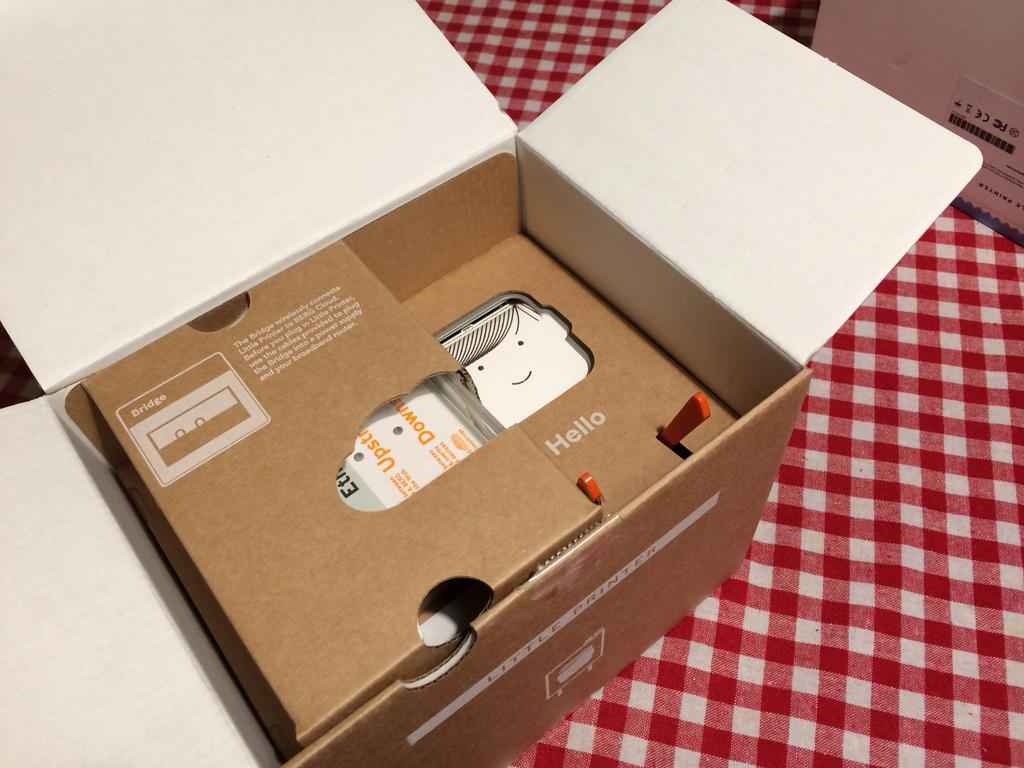How many boxes are visible in the image? There are two boxes in the image. What is the surface on which the boxes are placed? The boxes are on a cloth. Are there any objects inside either of the boxes? Yes, there are objects inside one of the boxes. How many babies are being treated by the grandfather in the image? There is no grandfather or babies present in the image. The image only features two boxes on a cloth, with objects inside one of the boxes. 